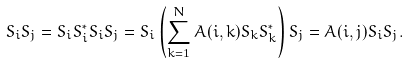Convert formula to latex. <formula><loc_0><loc_0><loc_500><loc_500>S _ { i } S _ { j } = S _ { i } S _ { i } ^ { * } S _ { i } S _ { j } = S _ { i } \left ( \sum _ { k = 1 } ^ { N } A ( i , k ) S _ { k } S _ { k } ^ { * } \right ) S _ { j } = A ( i , j ) S _ { i } S _ { j } .</formula> 